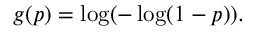<formula> <loc_0><loc_0><loc_500><loc_500>g ( p ) = \log ( - \log ( 1 - p ) ) .</formula> 